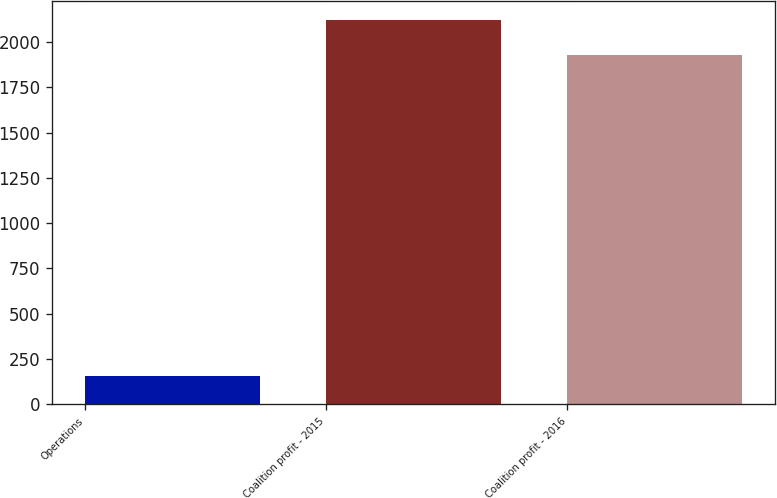<chart> <loc_0><loc_0><loc_500><loc_500><bar_chart><fcel>Operations<fcel>Coalition profit - 2015<fcel>Coalition profit - 2016<nl><fcel>154.9<fcel>2120.12<fcel>1930.2<nl></chart> 